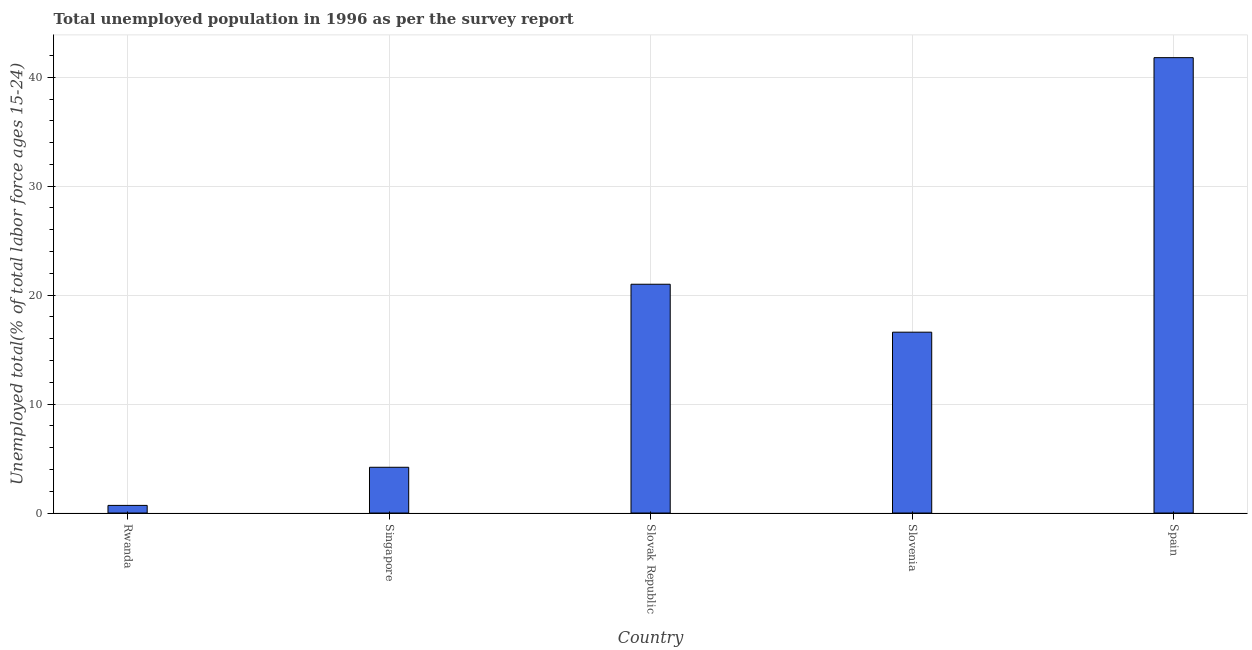Does the graph contain any zero values?
Offer a terse response. No. What is the title of the graph?
Your answer should be very brief. Total unemployed population in 1996 as per the survey report. What is the label or title of the X-axis?
Offer a terse response. Country. What is the label or title of the Y-axis?
Provide a short and direct response. Unemployed total(% of total labor force ages 15-24). What is the unemployed youth in Rwanda?
Give a very brief answer. 0.7. Across all countries, what is the maximum unemployed youth?
Provide a short and direct response. 41.8. Across all countries, what is the minimum unemployed youth?
Your answer should be very brief. 0.7. In which country was the unemployed youth maximum?
Keep it short and to the point. Spain. In which country was the unemployed youth minimum?
Your answer should be very brief. Rwanda. What is the sum of the unemployed youth?
Make the answer very short. 84.3. What is the difference between the unemployed youth in Rwanda and Slovenia?
Provide a succinct answer. -15.9. What is the average unemployed youth per country?
Your answer should be very brief. 16.86. What is the median unemployed youth?
Make the answer very short. 16.6. What is the ratio of the unemployed youth in Rwanda to that in Singapore?
Provide a short and direct response. 0.17. What is the difference between the highest and the second highest unemployed youth?
Provide a short and direct response. 20.8. Is the sum of the unemployed youth in Rwanda and Slovak Republic greater than the maximum unemployed youth across all countries?
Your answer should be compact. No. What is the difference between the highest and the lowest unemployed youth?
Ensure brevity in your answer.  41.1. In how many countries, is the unemployed youth greater than the average unemployed youth taken over all countries?
Make the answer very short. 2. How many bars are there?
Your answer should be very brief. 5. Are all the bars in the graph horizontal?
Ensure brevity in your answer.  No. What is the difference between two consecutive major ticks on the Y-axis?
Offer a terse response. 10. What is the Unemployed total(% of total labor force ages 15-24) in Rwanda?
Give a very brief answer. 0.7. What is the Unemployed total(% of total labor force ages 15-24) of Singapore?
Your answer should be very brief. 4.2. What is the Unemployed total(% of total labor force ages 15-24) in Slovenia?
Provide a succinct answer. 16.6. What is the Unemployed total(% of total labor force ages 15-24) of Spain?
Give a very brief answer. 41.8. What is the difference between the Unemployed total(% of total labor force ages 15-24) in Rwanda and Singapore?
Provide a succinct answer. -3.5. What is the difference between the Unemployed total(% of total labor force ages 15-24) in Rwanda and Slovak Republic?
Provide a short and direct response. -20.3. What is the difference between the Unemployed total(% of total labor force ages 15-24) in Rwanda and Slovenia?
Provide a succinct answer. -15.9. What is the difference between the Unemployed total(% of total labor force ages 15-24) in Rwanda and Spain?
Offer a very short reply. -41.1. What is the difference between the Unemployed total(% of total labor force ages 15-24) in Singapore and Slovak Republic?
Your answer should be compact. -16.8. What is the difference between the Unemployed total(% of total labor force ages 15-24) in Singapore and Spain?
Your response must be concise. -37.6. What is the difference between the Unemployed total(% of total labor force ages 15-24) in Slovak Republic and Slovenia?
Provide a short and direct response. 4.4. What is the difference between the Unemployed total(% of total labor force ages 15-24) in Slovak Republic and Spain?
Offer a very short reply. -20.8. What is the difference between the Unemployed total(% of total labor force ages 15-24) in Slovenia and Spain?
Your response must be concise. -25.2. What is the ratio of the Unemployed total(% of total labor force ages 15-24) in Rwanda to that in Singapore?
Your answer should be very brief. 0.17. What is the ratio of the Unemployed total(% of total labor force ages 15-24) in Rwanda to that in Slovak Republic?
Offer a terse response. 0.03. What is the ratio of the Unemployed total(% of total labor force ages 15-24) in Rwanda to that in Slovenia?
Your answer should be compact. 0.04. What is the ratio of the Unemployed total(% of total labor force ages 15-24) in Rwanda to that in Spain?
Give a very brief answer. 0.02. What is the ratio of the Unemployed total(% of total labor force ages 15-24) in Singapore to that in Slovenia?
Provide a succinct answer. 0.25. What is the ratio of the Unemployed total(% of total labor force ages 15-24) in Slovak Republic to that in Slovenia?
Make the answer very short. 1.26. What is the ratio of the Unemployed total(% of total labor force ages 15-24) in Slovak Republic to that in Spain?
Offer a very short reply. 0.5. What is the ratio of the Unemployed total(% of total labor force ages 15-24) in Slovenia to that in Spain?
Your answer should be compact. 0.4. 